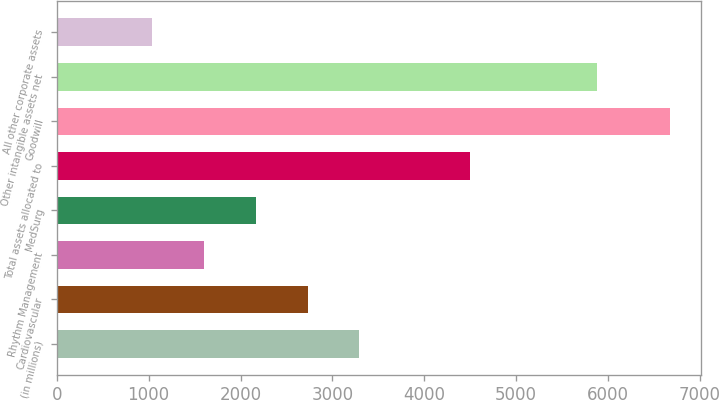Convert chart to OTSL. <chart><loc_0><loc_0><loc_500><loc_500><bar_chart><fcel>(in millions)<fcel>Cardiovascular<fcel>Rhythm Management<fcel>MedSurg<fcel>Total assets allocated to<fcel>Goodwill<fcel>Other intangible assets net<fcel>All other corporate assets<nl><fcel>3294<fcel>2730<fcel>1602<fcel>2166<fcel>4497<fcel>6678<fcel>5883<fcel>1038<nl></chart> 